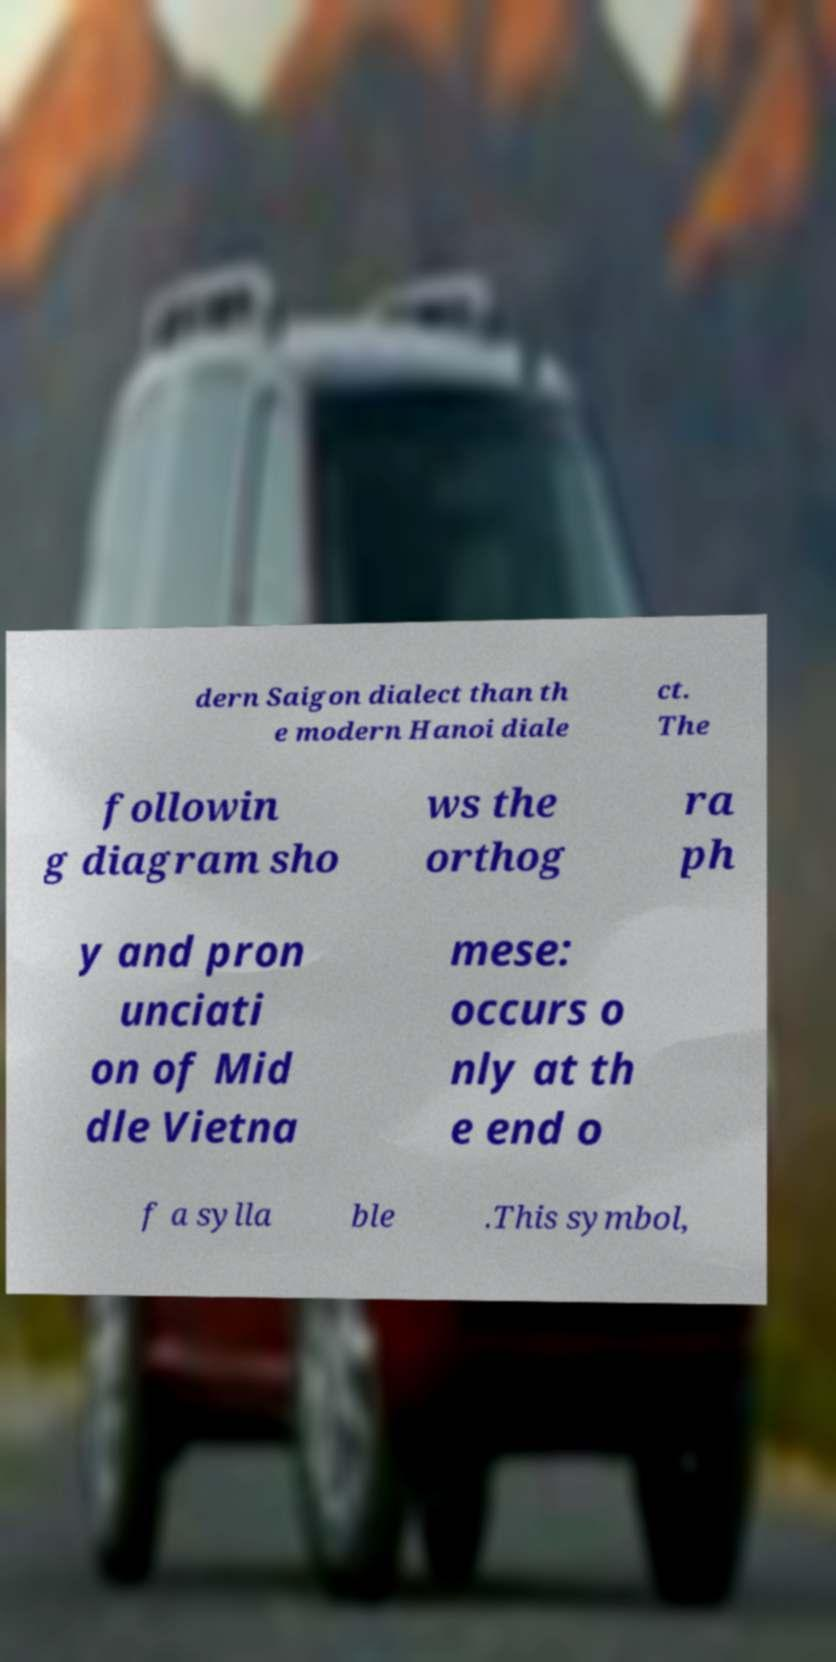Can you accurately transcribe the text from the provided image for me? dern Saigon dialect than th e modern Hanoi diale ct. The followin g diagram sho ws the orthog ra ph y and pron unciati on of Mid dle Vietna mese: occurs o nly at th e end o f a sylla ble .This symbol, 